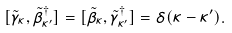Convert formula to latex. <formula><loc_0><loc_0><loc_500><loc_500>[ \tilde { \gamma } _ { \kappa } , \tilde { \beta } ^ { \dag } _ { \kappa ^ { \prime } } ] = [ \tilde { \beta } _ { \kappa } , \tilde { \gamma } ^ { \dag } _ { \kappa ^ { \prime } } ] = \delta ( \kappa - \kappa ^ { \prime } ) .</formula> 